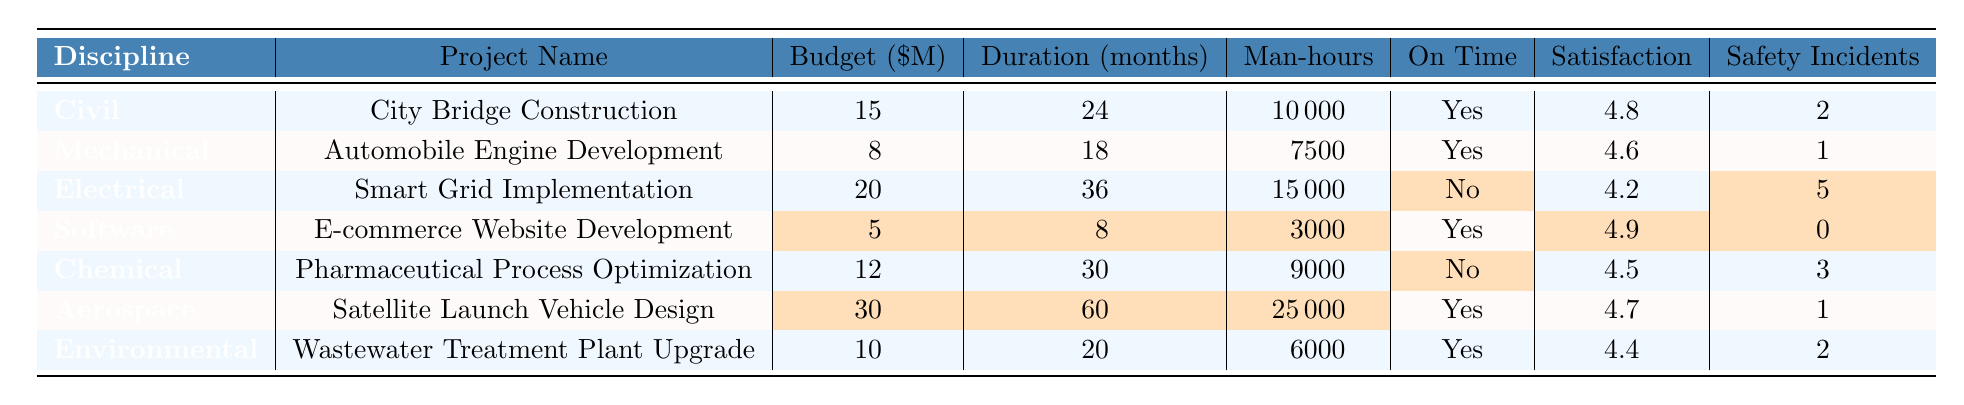What is the highest budget among the projects? The highest budget can be found by comparing the budget values listed in the table. The projects listed are City Bridge Construction ($15M), Automobile Engine Development ($8M), Smart Grid Implementation ($20M), E-commerce Website Development ($5M), Pharmaceutical Process Optimization ($12M), Satellite Launch Vehicle Design ($30M), and Wastewater Treatment Plant Upgrade ($10M). The highest value is $30M for the Satellite Launch Vehicle Design project.
Answer: $30M How many projects were completed on time? To find the number of projects completed on time, we can count the entries marked "Yes" under the On Time column. Looking through the table, the projects with "Yes" are: City Bridge Construction, Automobile Engine Development, E-commerce Website Development, Satellite Launch Vehicle Design, and Wastewater Treatment Plant Upgrade. This counts to 5 projects.
Answer: 5 What is the average customer satisfaction score for the projects? To calculate the average customer satisfaction score, we sum the scores: 4.8 + 4.6 + 4.2 + 4.9 + 4.5 + 4.7 + 4.4 = 32.1. Then we divide by the number of projects (7): 32.1 / 7 = 4.5857, which we can round to 4.6.
Answer: 4.6 Which discipline had the maximum number of safety incidents? We need to find the maximum safety incidents in the table by comparing the values from the Safety Incidents column. The values are: 2 (Civil), 1 (Mechanical), 5 (Electrical, highlighted), 0 (Software), 3 (Chemical), 1 (Aerospace), and 2 (Environmental). The maximum value is 5 safety incidents in Electrical Engineering.
Answer: Electrical Engineering Which project had the shortest duration? To answer this, we examine the duration values listed in the Duration (months) column: 24 (Civil), 18 (Mechanical), 36 (Electrical), 8 (Software, highlighted), 30 (Chemical), 60 (Aerospace), and 20 (Environmental). The shortest duration is 8 months for the E-commerce Website Development project.
Answer: 8 months Is there any project that had a budget less than $10 million but completed late? We check the budget and on-time completion status for each project together. The following projects have a budget less than $10 million: Automobile Engine Development ($8M, Yes), E-commerce Website Development ($5M, Yes), and none of the others meet both criteria. Since there are no entries with both a budget less than $10 million and a "No" for on-time completion, the answer is No.
Answer: No Which discipline had the lowest customer satisfaction score? We review the customer satisfaction scores: 4.8 (Civil), 4.6 (Mechanical), 4.2 (Electrical, highlighted), 4.9 (Software, highlighted), 4.5 (Chemical), 4.7 (Aerospace), and 4.4 (Environmental). The lowest score is 4.2, which belongs to Electrical Engineering.
Answer: Electrical Engineering How many safety incidents were reported in total across all projects? We sum the safety incident counts for each project: 2 (Civil) + 1 (Mechanical) + 5 (Electrical, highlighted) + 0 (Software) + 3 (Chemical) + 1 (Aerospace) + 2 (Environmental) = 14.
Answer: 14 